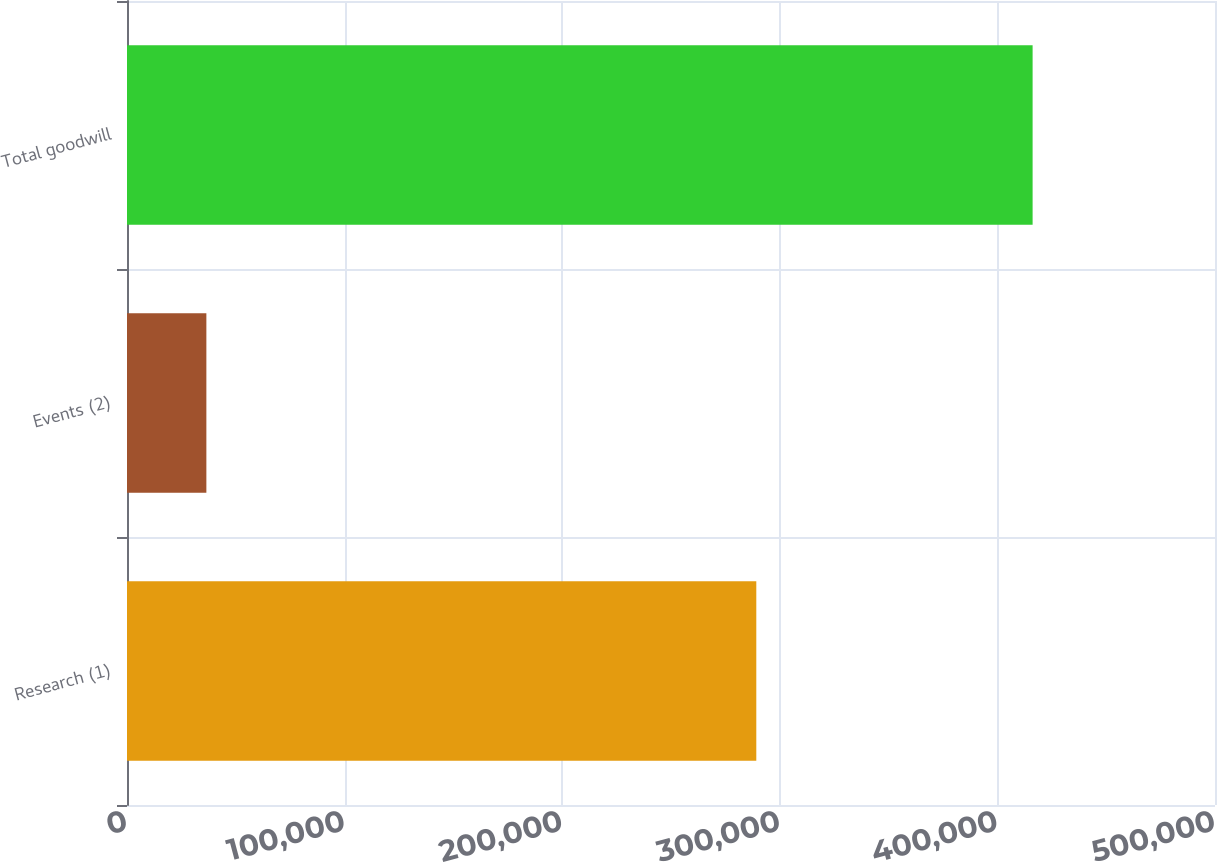<chart> <loc_0><loc_0><loc_500><loc_500><bar_chart><fcel>Research (1)<fcel>Events (2)<fcel>Total goodwill<nl><fcel>289199<fcel>36475<fcel>416181<nl></chart> 